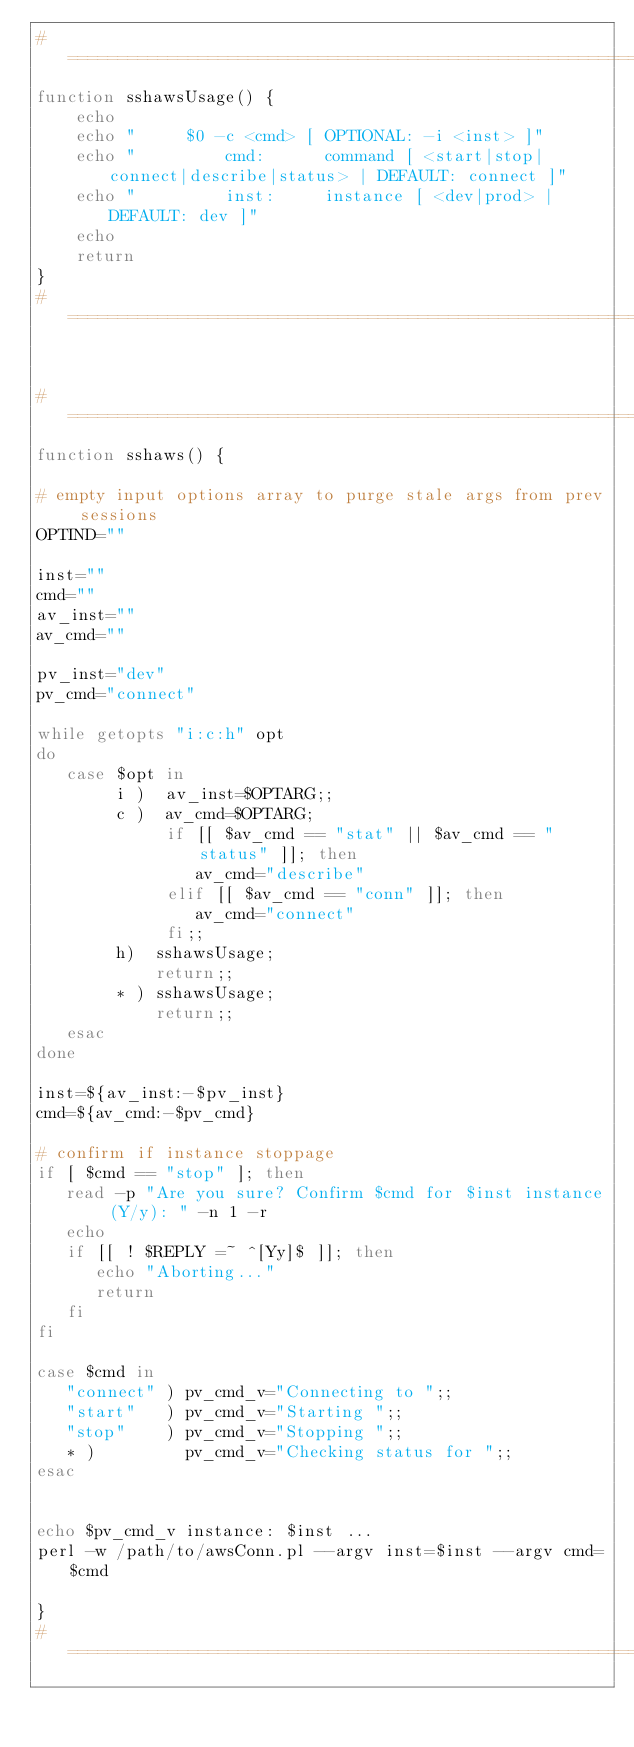Convert code to text. <code><loc_0><loc_0><loc_500><loc_500><_Bash_>#====================================================================
function sshawsUsage() {
    echo
    echo "     $0 -c <cmd> [ OPTIONAL: -i <inst> ]"
    echo "         cmd:      command [ <start|stop|connect|describe|status> | DEFAULT: connect ]"
    echo "         inst:     instance [ <dev|prod> | DEFAULT: dev ]"
    echo
    return
}
#====================================================================


#====================================================================
function sshaws() {

# empty input options array to purge stale args from prev sessions
OPTIND=""

inst=""
cmd=""
av_inst=""
av_cmd=""

pv_inst="dev"
pv_cmd="connect"

while getopts "i:c:h" opt
do
   case $opt in
        i )  av_inst=$OPTARG;;
        c )  av_cmd=$OPTARG;
             if [[ $av_cmd == "stat" || $av_cmd == "status" ]]; then
                av_cmd="describe"
             elif [[ $av_cmd == "conn" ]]; then
                av_cmd="connect"
             fi;;
        h)  sshawsUsage;
            return;;
        * ) sshawsUsage;
            return;;
   esac
done

inst=${av_inst:-$pv_inst}
cmd=${av_cmd:-$pv_cmd}

# confirm if instance stoppage
if [ $cmd == "stop" ]; then
   read -p "Are you sure? Confirm $cmd for $inst instance (Y/y): " -n 1 -r
   echo
   if [[ ! $REPLY =~ ^[Yy]$ ]]; then
      echo "Aborting..."
      return
   fi
fi

case $cmd in
   "connect" ) pv_cmd_v="Connecting to ";;
   "start"   ) pv_cmd_v="Starting ";;
   "stop"    ) pv_cmd_v="Stopping ";;
   * )         pv_cmd_v="Checking status for ";;
esac


echo $pv_cmd_v instance: $inst ...
perl -w /path/to/awsConn.pl --argv inst=$inst --argv cmd=$cmd

}
#====================================================================

</code> 